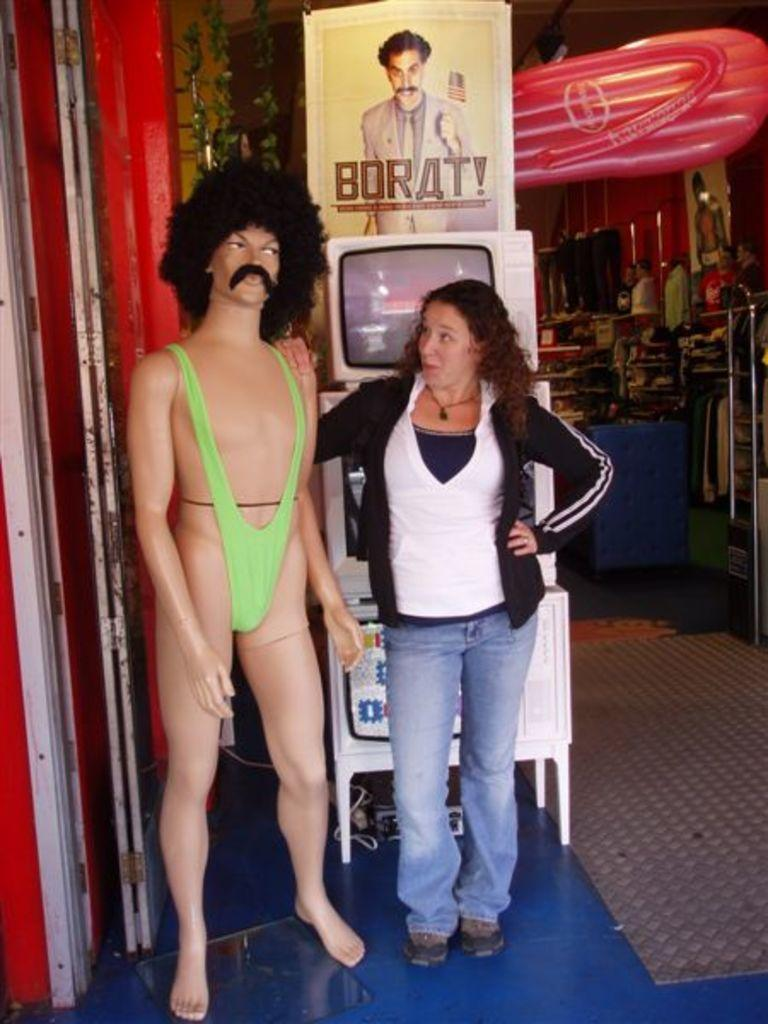What type of store is depicted in the image? There is an apparel store in the image. What other types of products can be found in the store? The store includes electronic gadgets and shoes. Are there any people present in the image? Yes, there are people in the image. What can be seen on the floor of the store? There is a floor mat in the image. Can you describe any other objects present in the image? There are other objects present in the image, but their specific details are not mentioned in the provided facts. What direction is the gun pointing in the image? There is no gun present in the image. What type of books can be seen on the shelves in the image? There are no books present in the image. 